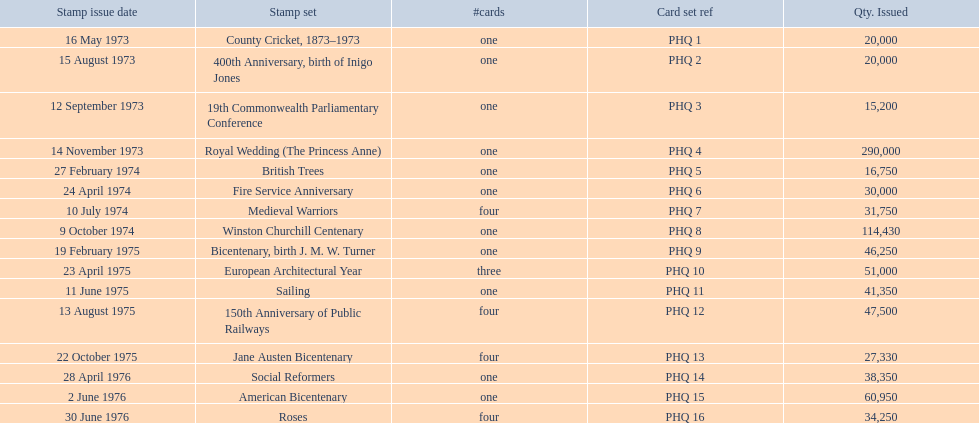Which stamp sets can be found in the phq? County Cricket, 1873–1973, 400th Anniversary, birth of Inigo Jones, 19th Commonwealth Parliamentary Conference, Royal Wedding (The Princess Anne), British Trees, Fire Service Anniversary, Medieval Warriors, Winston Churchill Centenary, Bicentenary, birth J. M. W. Turner, European Architectural Year, Sailing, 150th Anniversary of Public Railways, Jane Austen Bicentenary, Social Reformers, American Bicentenary, Roses. Which stamp sets come with over 200,000 quantities issued? Royal Wedding (The Princess Anne). 